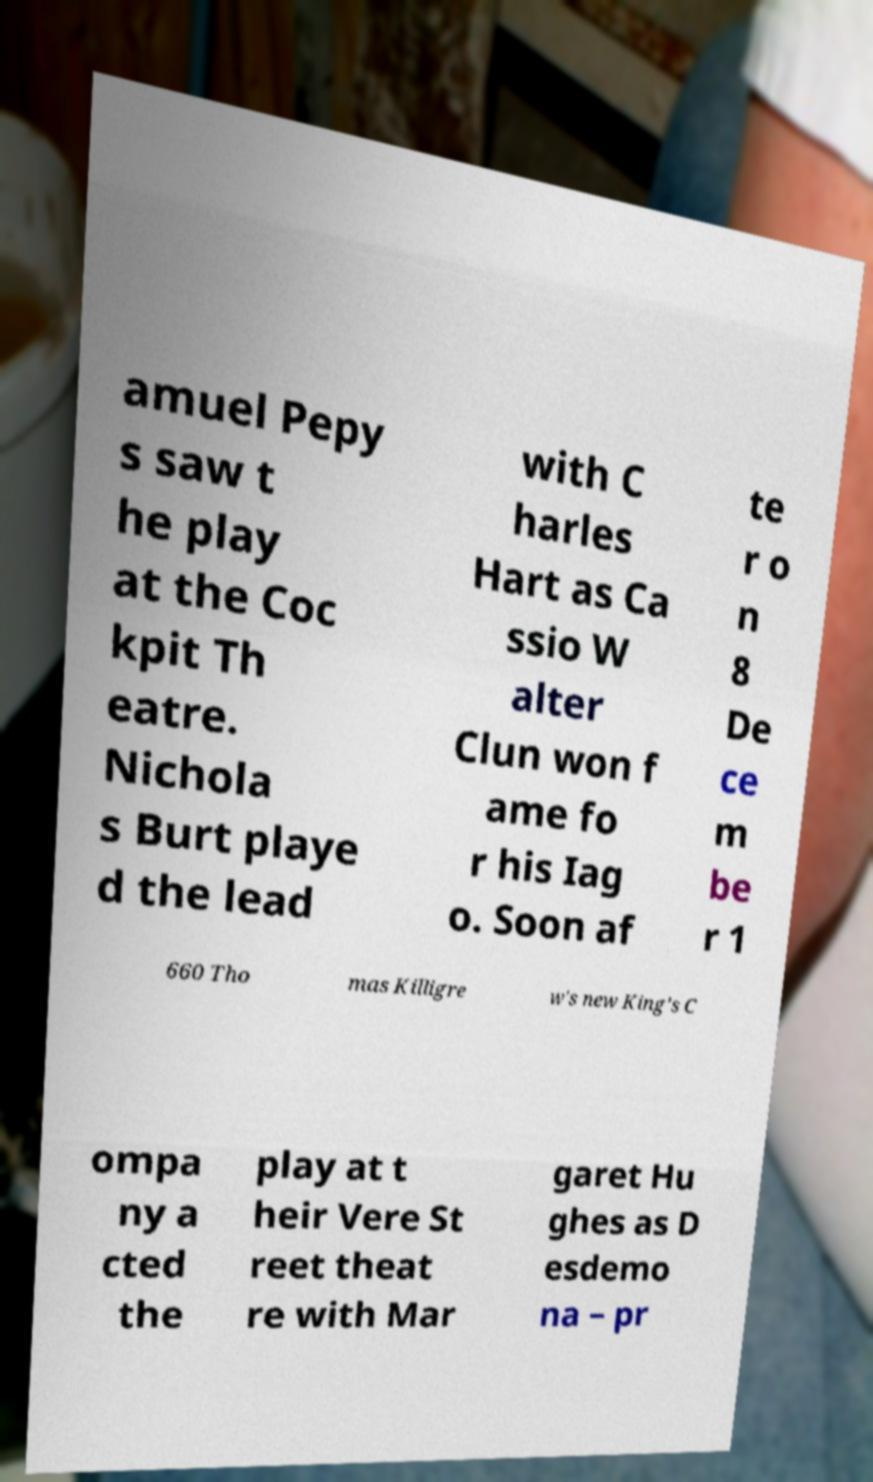For documentation purposes, I need the text within this image transcribed. Could you provide that? amuel Pepy s saw t he play at the Coc kpit Th eatre. Nichola s Burt playe d the lead with C harles Hart as Ca ssio W alter Clun won f ame fo r his Iag o. Soon af te r o n 8 De ce m be r 1 660 Tho mas Killigre w's new King's C ompa ny a cted the play at t heir Vere St reet theat re with Mar garet Hu ghes as D esdemo na – pr 